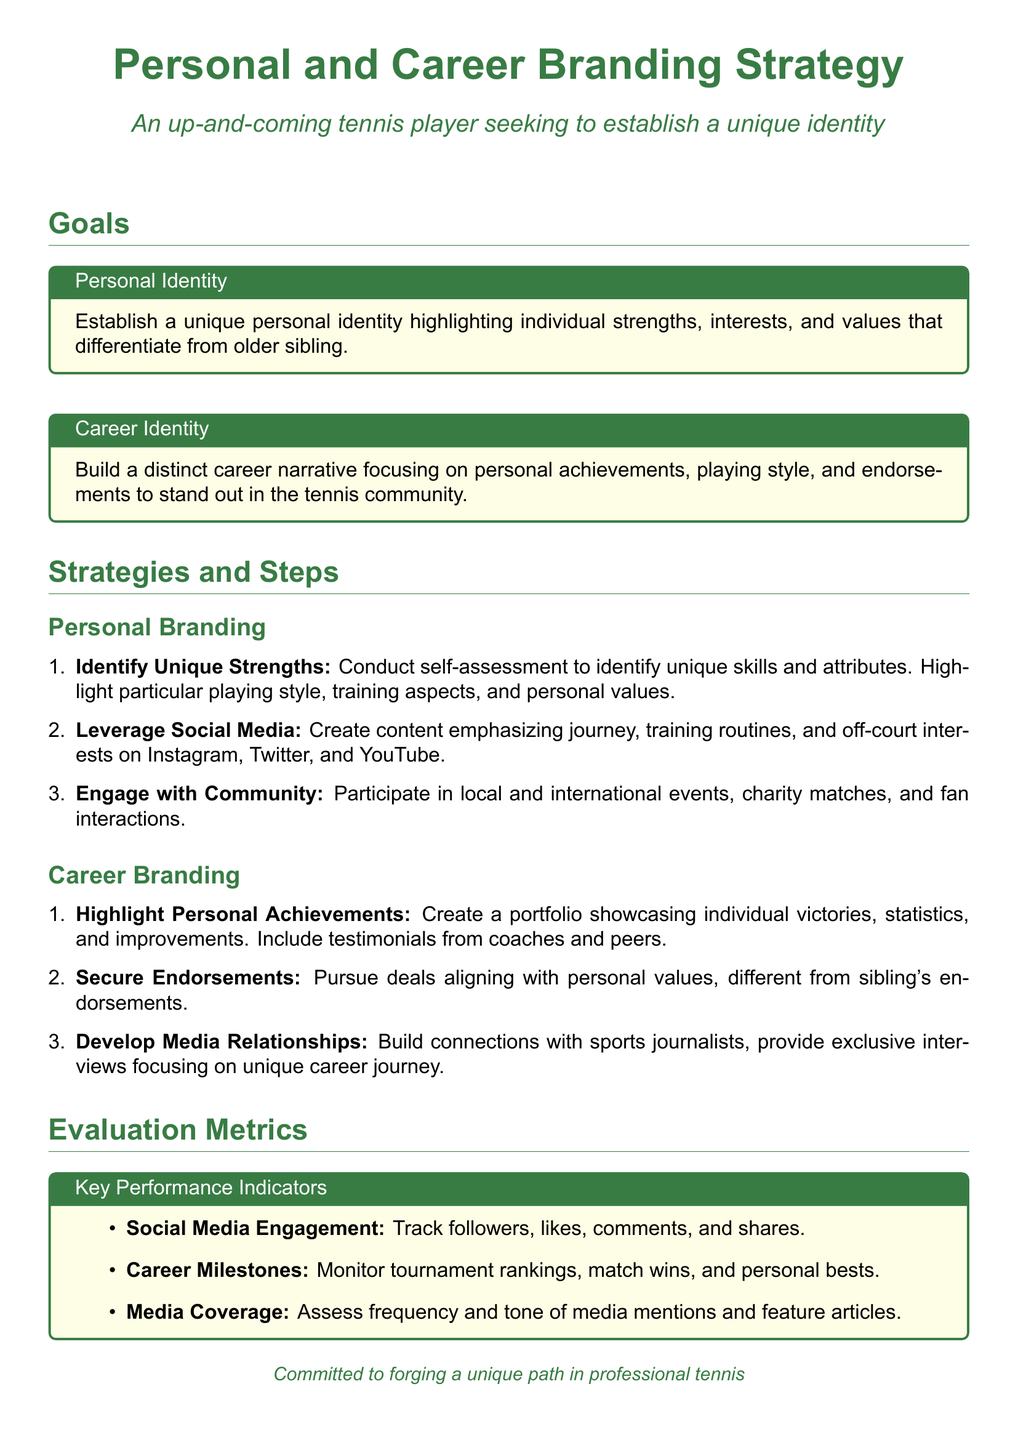What is the document about? The document outlines a Personal and Career Branding Strategy for an up-and-coming tennis player.
Answer: Personal and Career Branding Strategy What are the two main goals outlined in the document? The document specifies two main goals: personal identity and career identity.
Answer: Personal Identity and Career Identity How many strategies are listed under Personal Branding? There are three strategies listed under Personal Branding.
Answer: Three What is the first step in the Career Branding section? The first step in the Career Branding section is to highlight personal achievements.
Answer: Highlight Personal Achievements What metrics are used to evaluate the branding strategy? The document mentions social media engagement, career milestones, and media coverage as evaluation metrics.
Answer: Social Media Engagement, Career Milestones, Media Coverage Which social media platforms are suggested for leveraging content? The platforms suggested are Instagram, Twitter, and YouTube.
Answer: Instagram, Twitter, YouTube What is the color used for titles in the document? The color used for titles in the document is tennis green.
Answer: Tennis Green How is the document structured? The document consists of sections on goals, strategies and steps, and evaluation metrics.
Answer: Goals, Strategies and Steps, Evaluation Metrics 